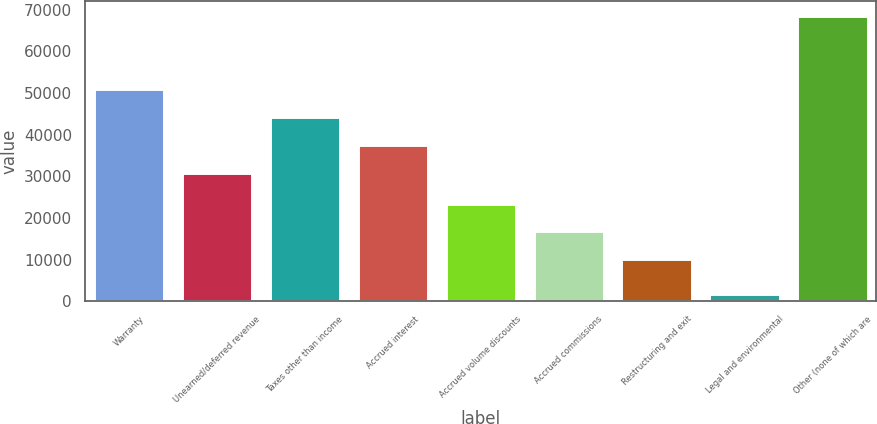Convert chart to OTSL. <chart><loc_0><loc_0><loc_500><loc_500><bar_chart><fcel>Warranty<fcel>Unearned/deferred revenue<fcel>Taxes other than income<fcel>Accrued interest<fcel>Accrued volume discounts<fcel>Accrued commissions<fcel>Restructuring and exit<fcel>Legal and environmental<fcel>Other (none of which are<nl><fcel>50899.3<fcel>30817<fcel>44205.2<fcel>37511.1<fcel>23434.2<fcel>16740.1<fcel>10046<fcel>1623<fcel>68564<nl></chart> 